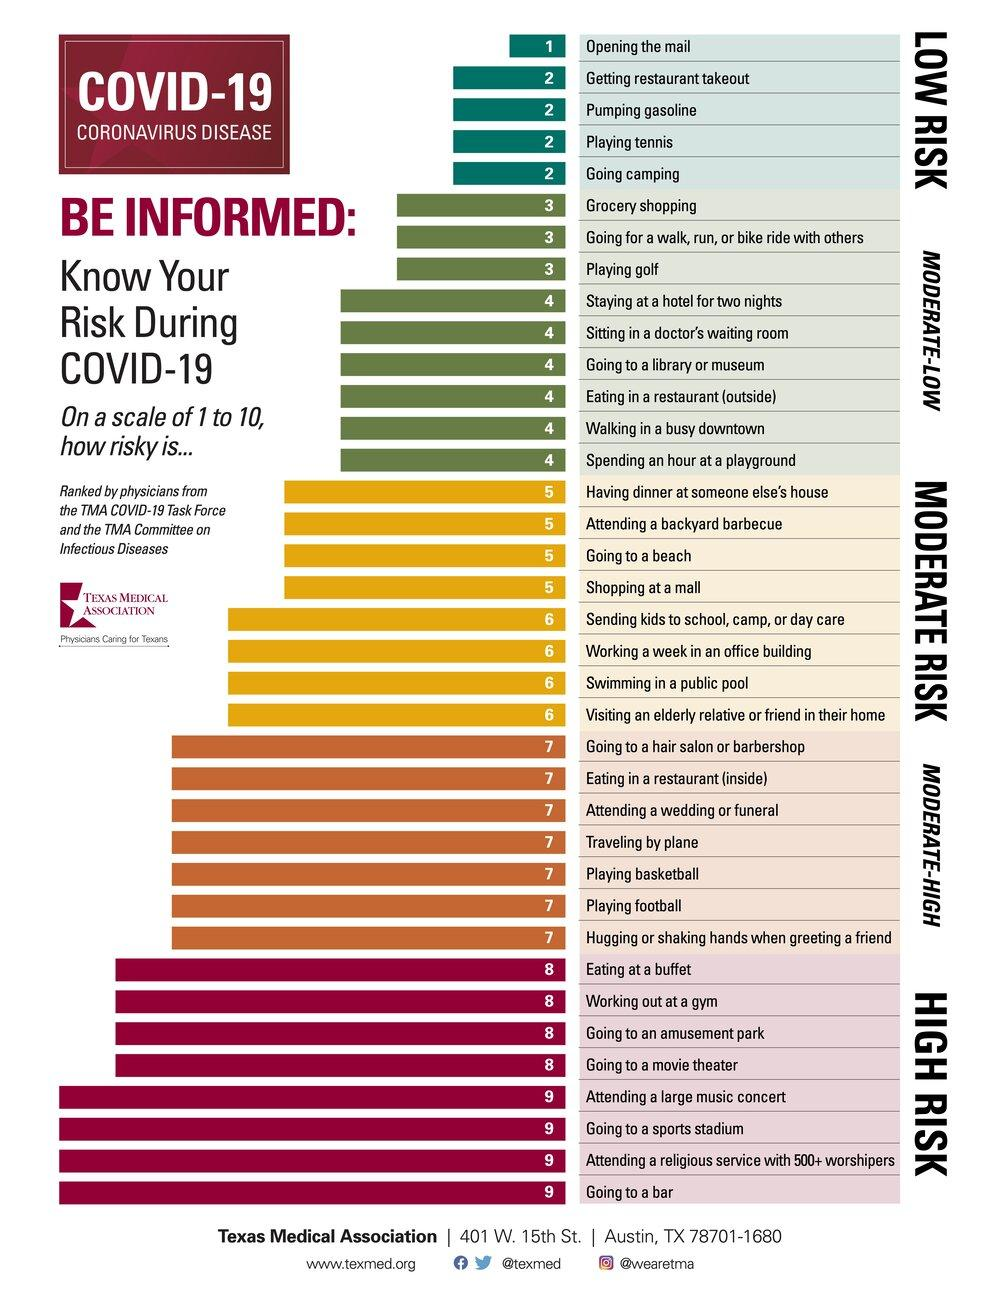Mention a couple of crucial points in this snapshot. The third item listed in the moderate risk category is visiting a beach. The risk of COVID-19 infection is higher for individuals who travel by plane than for those who go camping. Attending a religious service with above 500 worshippers is associated with a high risk category. Playing football is categorized as a moderate-high risk activity. Grocery shopping is categorized as a moderate-low risk activity. 